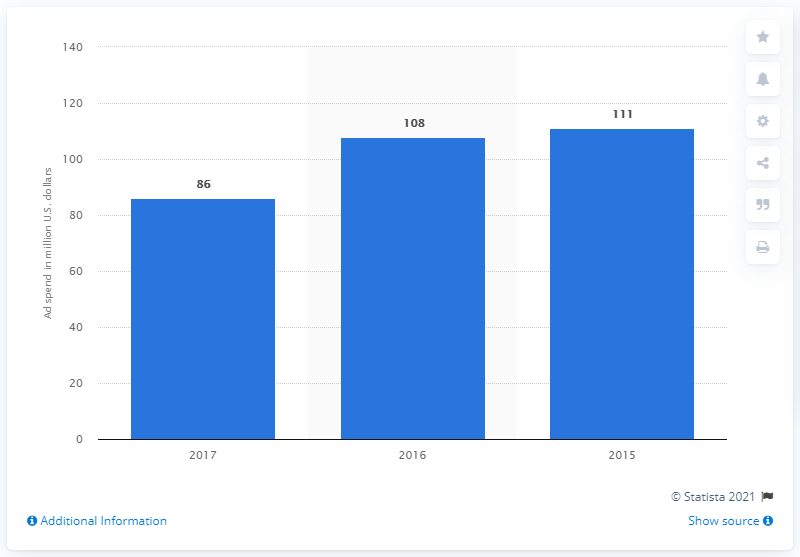Point out several critical features in this image. The ad spend of Wyndham Worldwide Corporation in 2017 was approximately 111... 